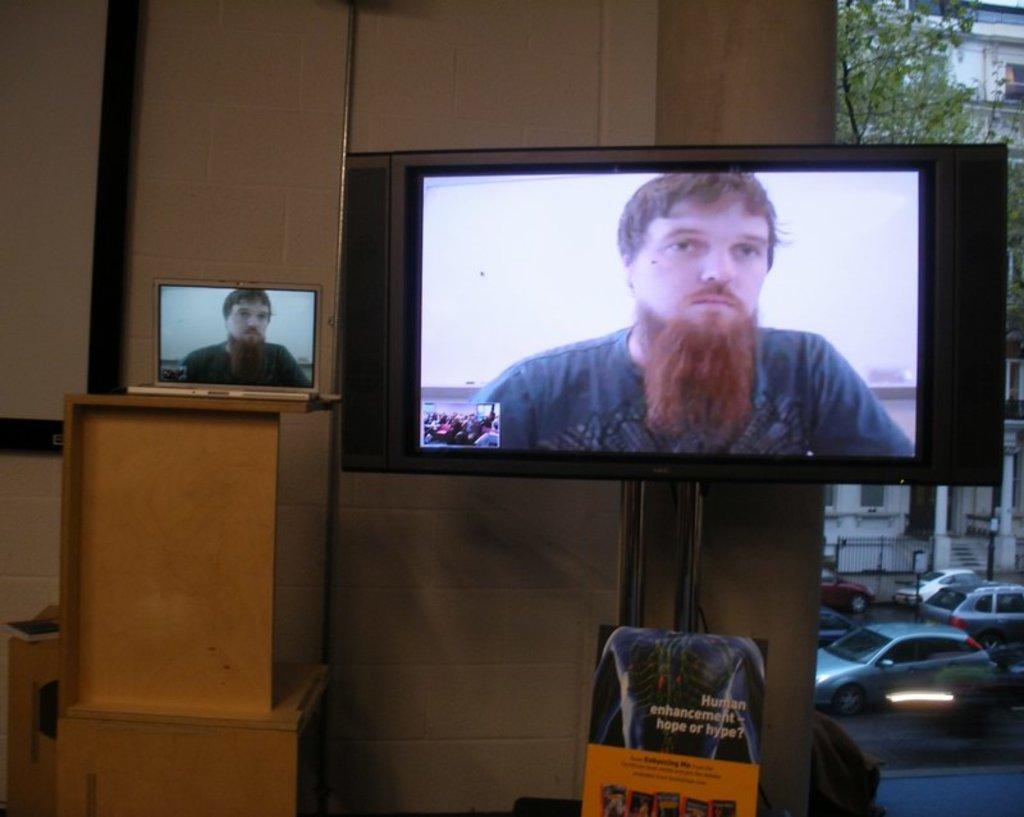How would you summarize this image in a sentence or two? In this image I can see a monitor which is attached to the wall. At the bottom there is a chair. On the screen, I can see a man. On the left side there is a table on which a laptop is placed. On the right side there are few cars on the road and also I can see a building and trees. 